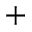Convert formula to latex. <formula><loc_0><loc_0><loc_500><loc_500>+</formula> 